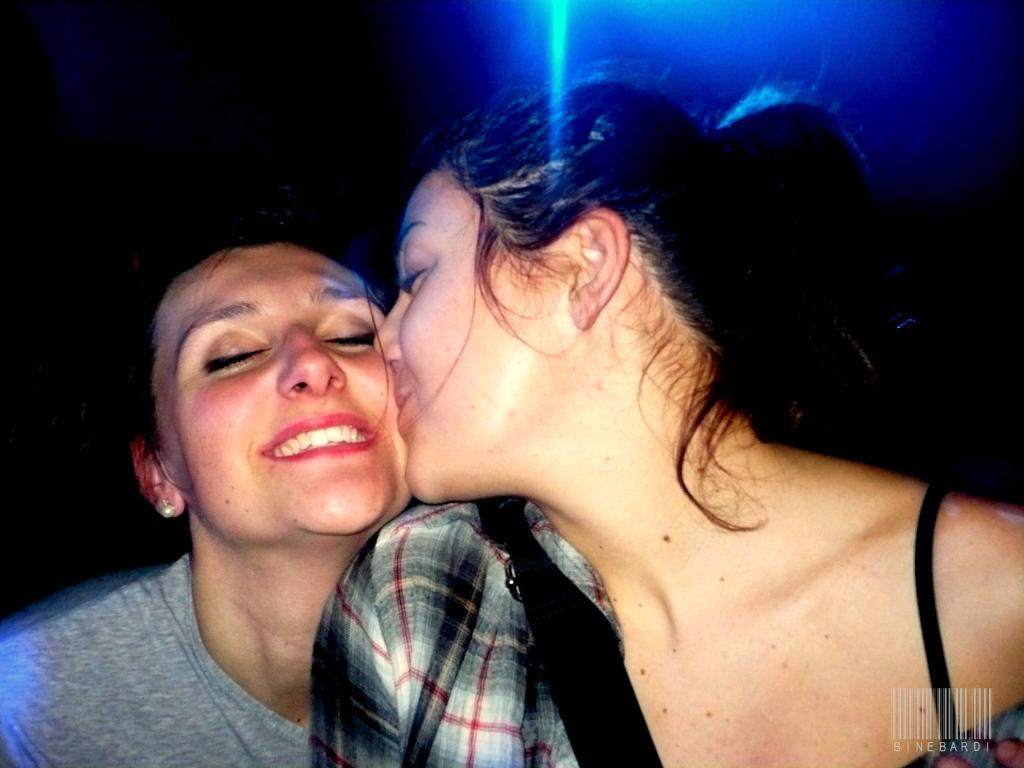How many women are in the image? There are two women in the image. What is the woman in the gray t-shirt wearing? The woman in the gray t-shirt is wearing a gray t-shirt. What is the facial expression of the woman in the gray t-shirt? The woman in the gray t-shirt is smiling. What can be seen at the top of the image? There is a light visible at the top of the image. Can you see any steam coming from the ocean in the image? There is no ocean or steam present in the image. Is there a boat visible in the image? There is no boat present in the image. 